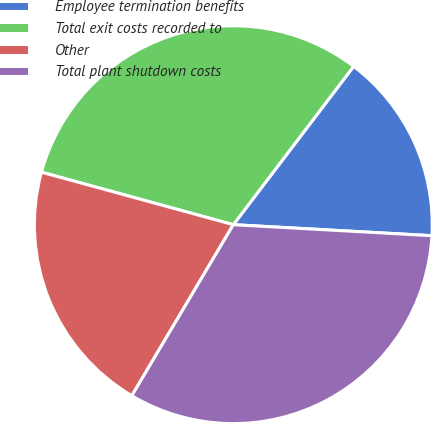Convert chart. <chart><loc_0><loc_0><loc_500><loc_500><pie_chart><fcel>Employee termination benefits<fcel>Total exit costs recorded to<fcel>Other<fcel>Total plant shutdown costs<nl><fcel>15.54%<fcel>31.09%<fcel>20.73%<fcel>32.64%<nl></chart> 